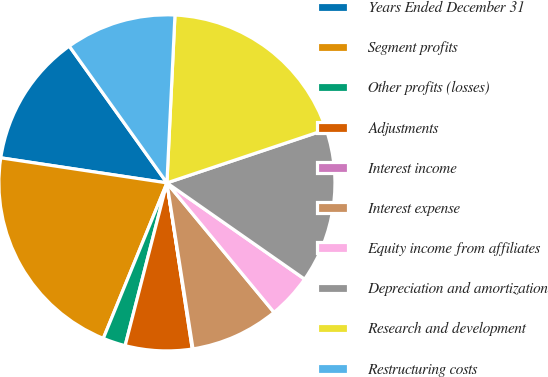Convert chart. <chart><loc_0><loc_0><loc_500><loc_500><pie_chart><fcel>Years Ended December 31<fcel>Segment profits<fcel>Other profits (losses)<fcel>Adjustments<fcel>Interest income<fcel>Interest expense<fcel>Equity income from affiliates<fcel>Depreciation and amortization<fcel>Research and development<fcel>Restructuring costs<nl><fcel>12.75%<fcel>21.2%<fcel>2.18%<fcel>6.41%<fcel>0.07%<fcel>8.52%<fcel>4.29%<fcel>14.86%<fcel>19.09%<fcel>10.63%<nl></chart> 